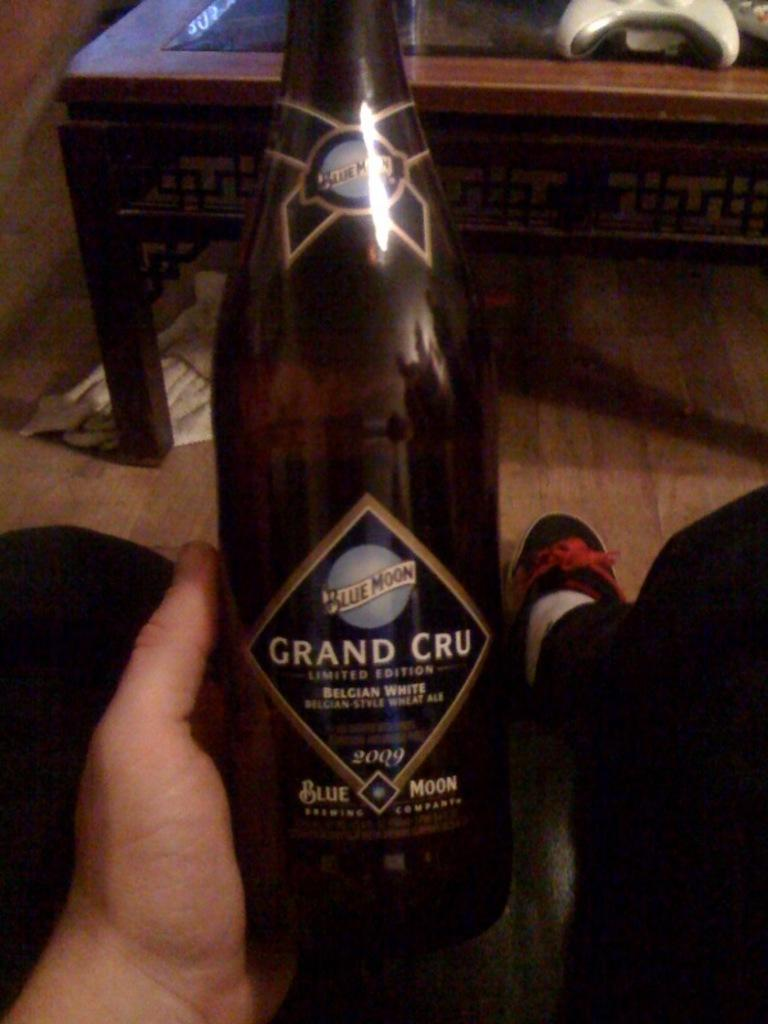<image>
Describe the image concisely. A person is holding a bottle of Blue Moon Grand Cru. 